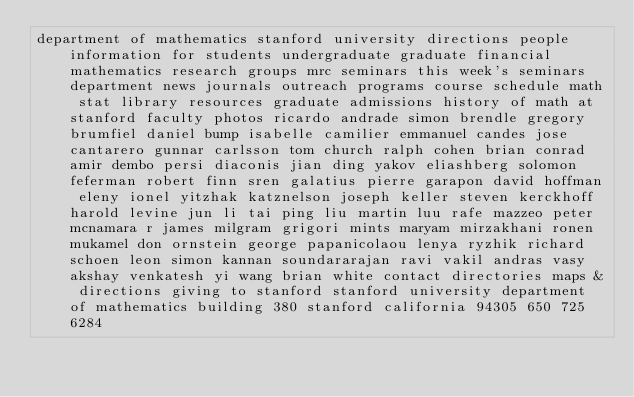<code> <loc_0><loc_0><loc_500><loc_500><_HTML_>department of mathematics stanford university directions people information for students undergraduate graduate financial mathematics research groups mrc seminars this week's seminars department news journals outreach programs course schedule math stat library resources graduate admissions history of math at stanford faculty photos ricardo andrade simon brendle gregory brumfiel daniel bump isabelle camilier emmanuel candes jose cantarero gunnar carlsson tom church ralph cohen brian conrad amir dembo persi diaconis jian ding yakov eliashberg solomon feferman robert finn sren galatius pierre garapon david hoffman eleny ionel yitzhak katznelson joseph keller steven kerckhoff harold levine jun li tai ping liu martin luu rafe mazzeo peter mcnamara r james milgram grigori mints maryam mirzakhani ronen mukamel don ornstein george papanicolaou lenya ryzhik richard schoen leon simon kannan soundararajan ravi vakil andras vasy akshay venkatesh yi wang brian white contact directories maps & directions giving to stanford stanford university department of mathematics building 380 stanford california 94305 650 725 6284
</code> 